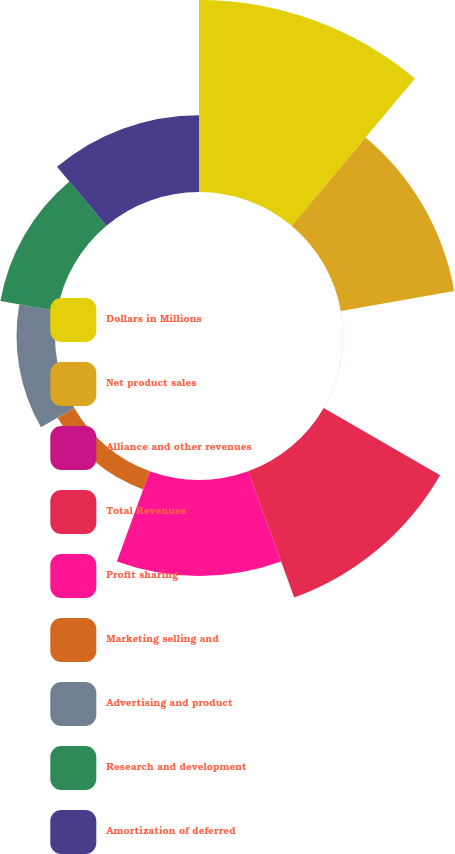Convert chart. <chart><loc_0><loc_0><loc_500><loc_500><pie_chart><fcel>Dollars in Millions<fcel>Net product sales<fcel>Alliance and other revenues<fcel>Total Revenues<fcel>Profit sharing<fcel>Marketing selling and<fcel>Advertising and product<fcel>Research and development<fcel>Amortization of deferred<nl><fcel>26.3%<fcel>15.78%<fcel>0.01%<fcel>18.41%<fcel>13.16%<fcel>2.64%<fcel>5.27%<fcel>7.9%<fcel>10.53%<nl></chart> 